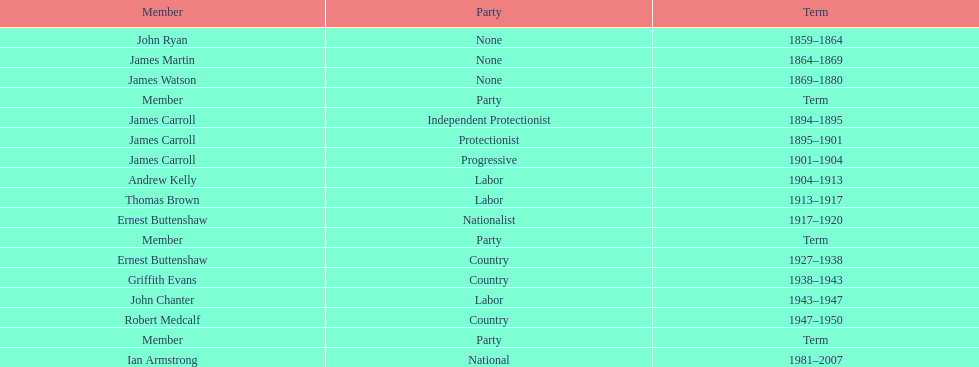How long did the fourth incarnation of the lachlan exist? 1981-2007. 